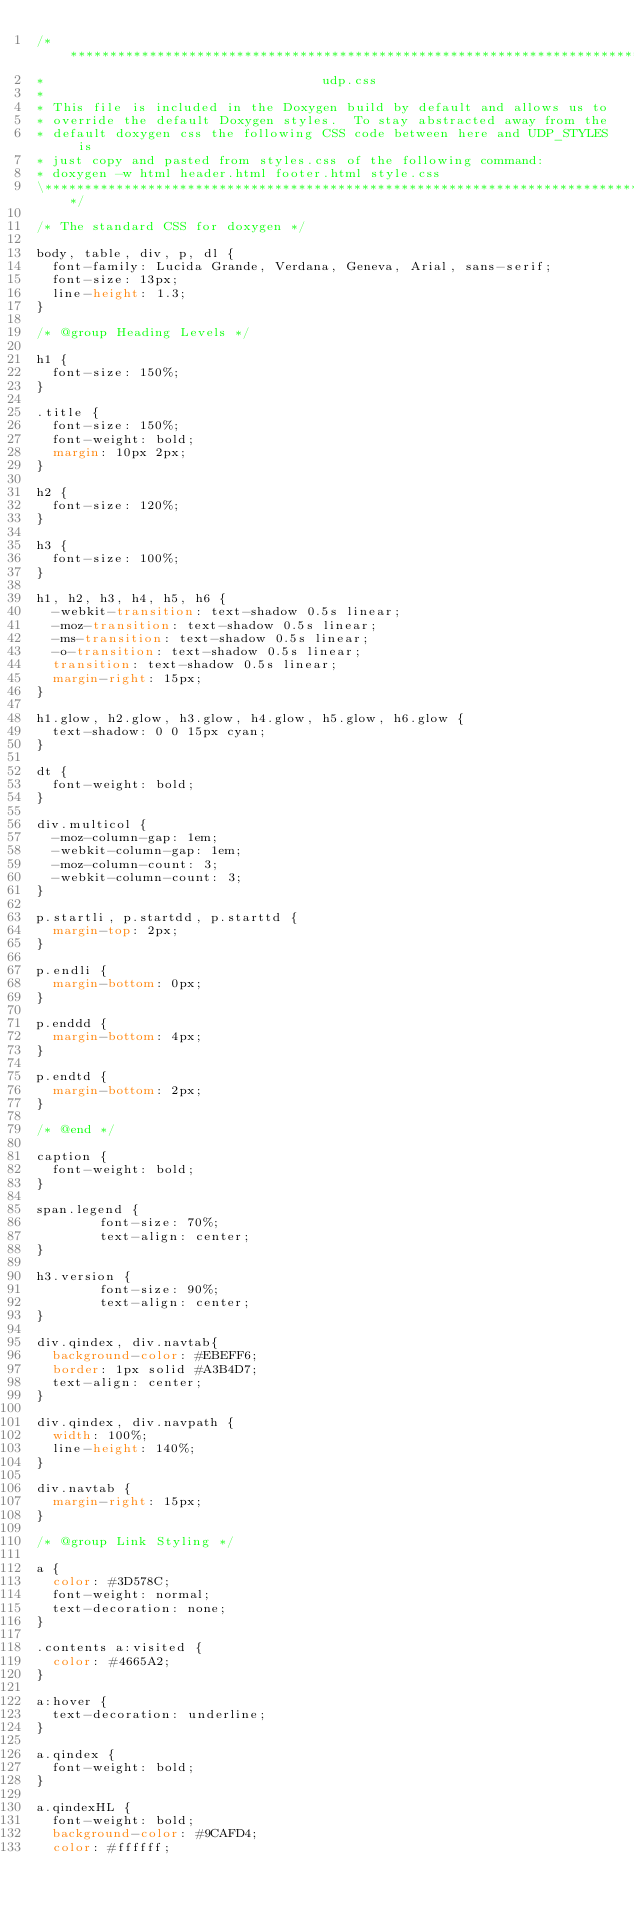Convert code to text. <code><loc_0><loc_0><loc_500><loc_500><_CSS_>/*****************************************************************************\
*                                   udp.css
*
* This file is included in the Doxygen build by default and allows us to
* override the default Doxygen styles.  To stay abstracted away from the
* default doxygen css the following CSS code between here and UDP_STYLES is
* just copy and pasted from styles.css of the following command:
* doxygen -w html header.html footer.html style.css
\*****************************************************************************/

/* The standard CSS for doxygen */

body, table, div, p, dl {
	font-family: Lucida Grande, Verdana, Geneva, Arial, sans-serif;
	font-size: 13px;
	line-height: 1.3;
}

/* @group Heading Levels */

h1 {
	font-size: 150%;
}

.title {
	font-size: 150%;
	font-weight: bold;
	margin: 10px 2px;
}

h2 {
	font-size: 120%;
}

h3 {
	font-size: 100%;
}

h1, h2, h3, h4, h5, h6 {
	-webkit-transition: text-shadow 0.5s linear;
	-moz-transition: text-shadow 0.5s linear;
	-ms-transition: text-shadow 0.5s linear;
	-o-transition: text-shadow 0.5s linear;
	transition: text-shadow 0.5s linear;
	margin-right: 15px;
}

h1.glow, h2.glow, h3.glow, h4.glow, h5.glow, h6.glow {
	text-shadow: 0 0 15px cyan;
}

dt {
	font-weight: bold;
}

div.multicol {
	-moz-column-gap: 1em;
	-webkit-column-gap: 1em;
	-moz-column-count: 3;
	-webkit-column-count: 3;
}

p.startli, p.startdd, p.starttd {
	margin-top: 2px;
}

p.endli {
	margin-bottom: 0px;
}

p.enddd {
	margin-bottom: 4px;
}

p.endtd {
	margin-bottom: 2px;
}

/* @end */

caption {
	font-weight: bold;
}

span.legend {
        font-size: 70%;
        text-align: center;
}

h3.version {
        font-size: 90%;
        text-align: center;
}

div.qindex, div.navtab{
	background-color: #EBEFF6;
	border: 1px solid #A3B4D7;
	text-align: center;
}

div.qindex, div.navpath {
	width: 100%;
	line-height: 140%;
}

div.navtab {
	margin-right: 15px;
}

/* @group Link Styling */

a {
	color: #3D578C;
	font-weight: normal;
	text-decoration: none;
}

.contents a:visited {
	color: #4665A2;
}

a:hover {
	text-decoration: underline;
}

a.qindex {
	font-weight: bold;
}

a.qindexHL {
	font-weight: bold;
	background-color: #9CAFD4;
	color: #ffffff;</code> 